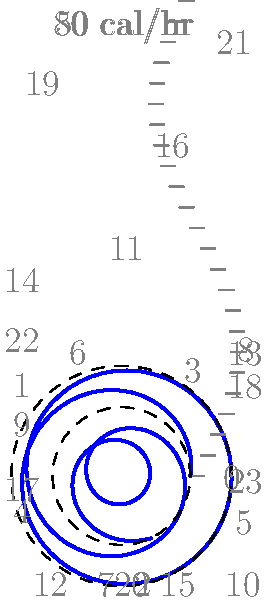As a fitness trainer, you want to represent a client's calorie burn throughout the day using a polar graph. The graph shows calorie burn as a spiral, where the distance from the center represents calories burned per hour, and the angle represents the time of day. If the client's base metabolic rate is 50 calories per hour and their activity level fluctuates with a sinusoidal pattern of amplitude 30 calories per hour, what is the maximum calorie burn per hour shown on the graph? To find the maximum calorie burn per hour, we need to analyze the given information and the polar graph:

1. The client's base metabolic rate is 50 calories per hour. This is represented by the inner dashed circle on the graph.

2. The activity level fluctuates with a sinusoidal pattern. The amplitude of this fluctuation is 30 calories per hour.

3. The calorie burn rate at any given time can be represented by the function:

   $$f(t) = 50 + 30 \sin(\frac{2\pi t}{24})$$

   where $t$ is the time in hours (0-24) and $f(t)$ is the calorie burn rate.

4. To find the maximum value, we need to find when the sine function reaches its peak, which is 1.

5. When $\sin(\frac{2\pi t}{24}) = 1$, the function will reach its maximum value:

   $$f_{max} = 50 + 30(1) = 80$$

6. This maximum value of 80 calories per hour is represented by the outer dashed circle on the graph.

Therefore, the maximum calorie burn per hour shown on the graph is 80 calories.
Answer: 80 calories per hour 